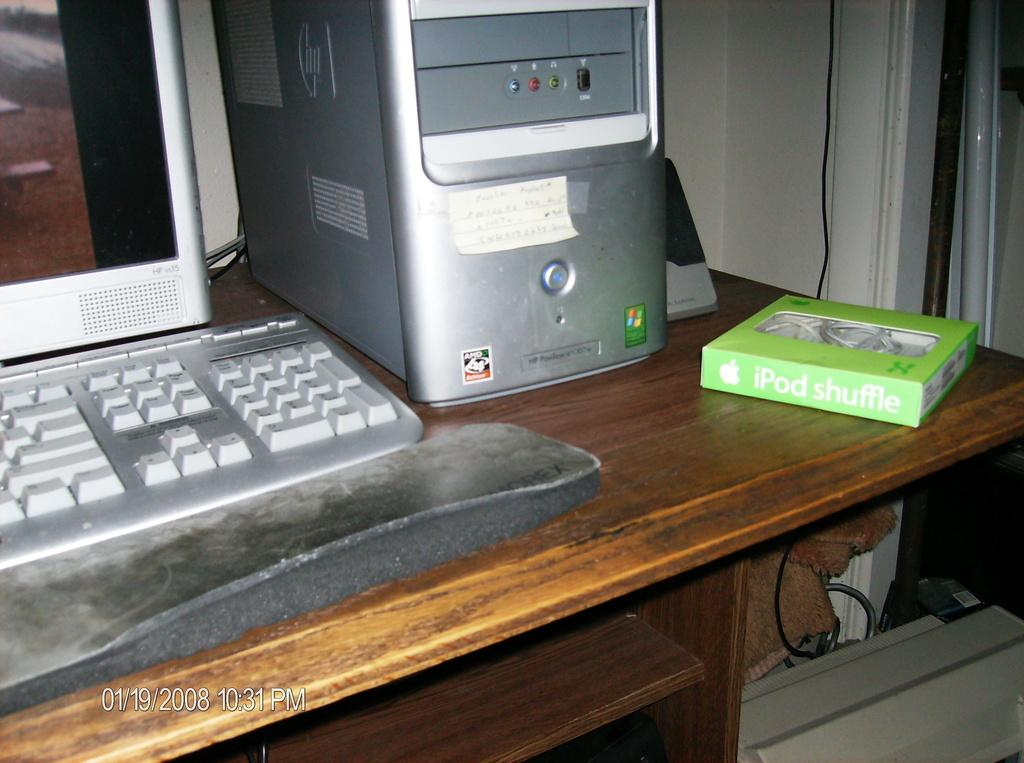Provide a one-sentence caption for the provided image. A vintage silver computer with a neon green Ipod shuffle box next to it. 